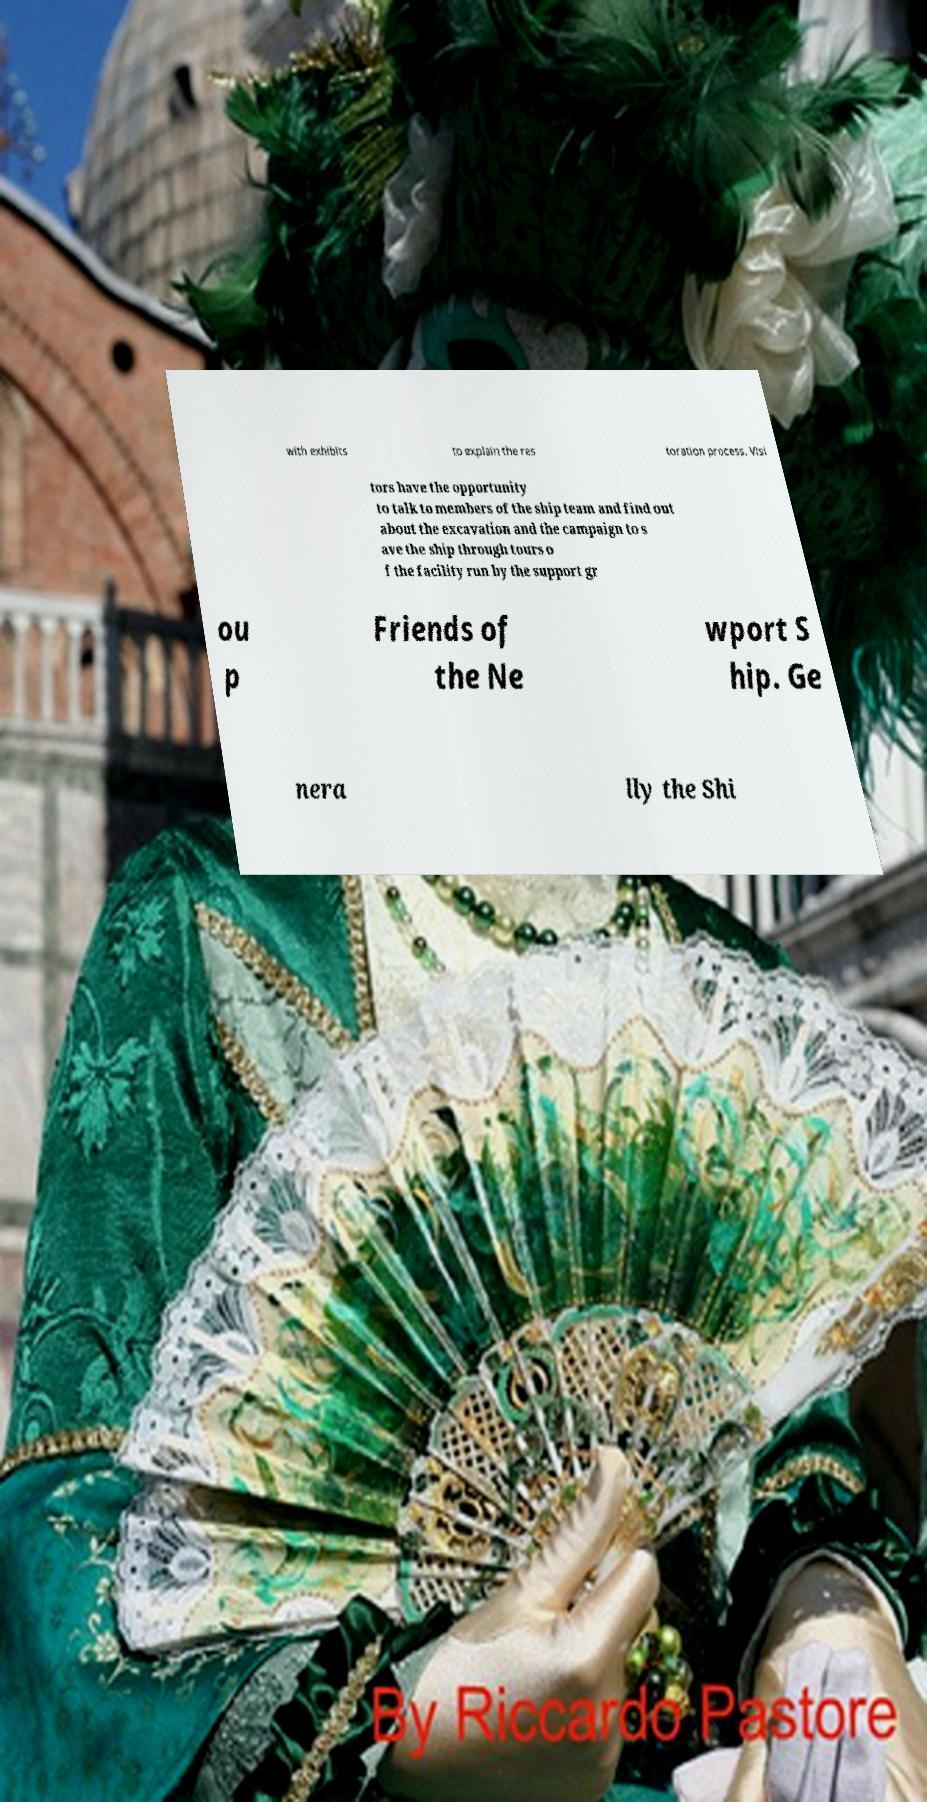Could you assist in decoding the text presented in this image and type it out clearly? with exhibits to explain the res toration process. Visi tors have the opportunity to talk to members of the ship team and find out about the excavation and the campaign to s ave the ship through tours o f the facility run by the support gr ou p Friends of the Ne wport S hip. Ge nera lly the Shi 